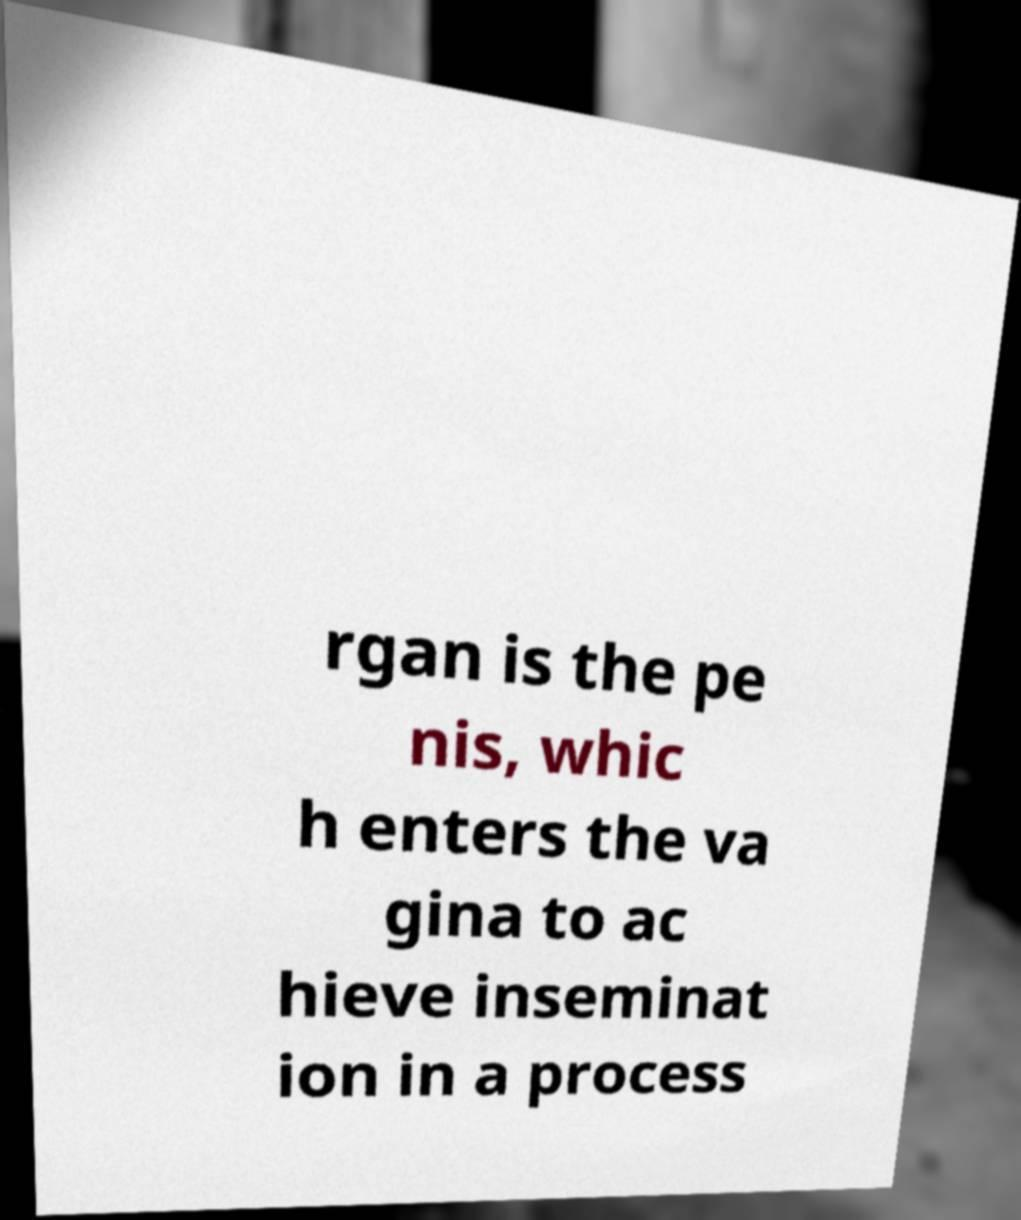There's text embedded in this image that I need extracted. Can you transcribe it verbatim? rgan is the pe nis, whic h enters the va gina to ac hieve inseminat ion in a process 